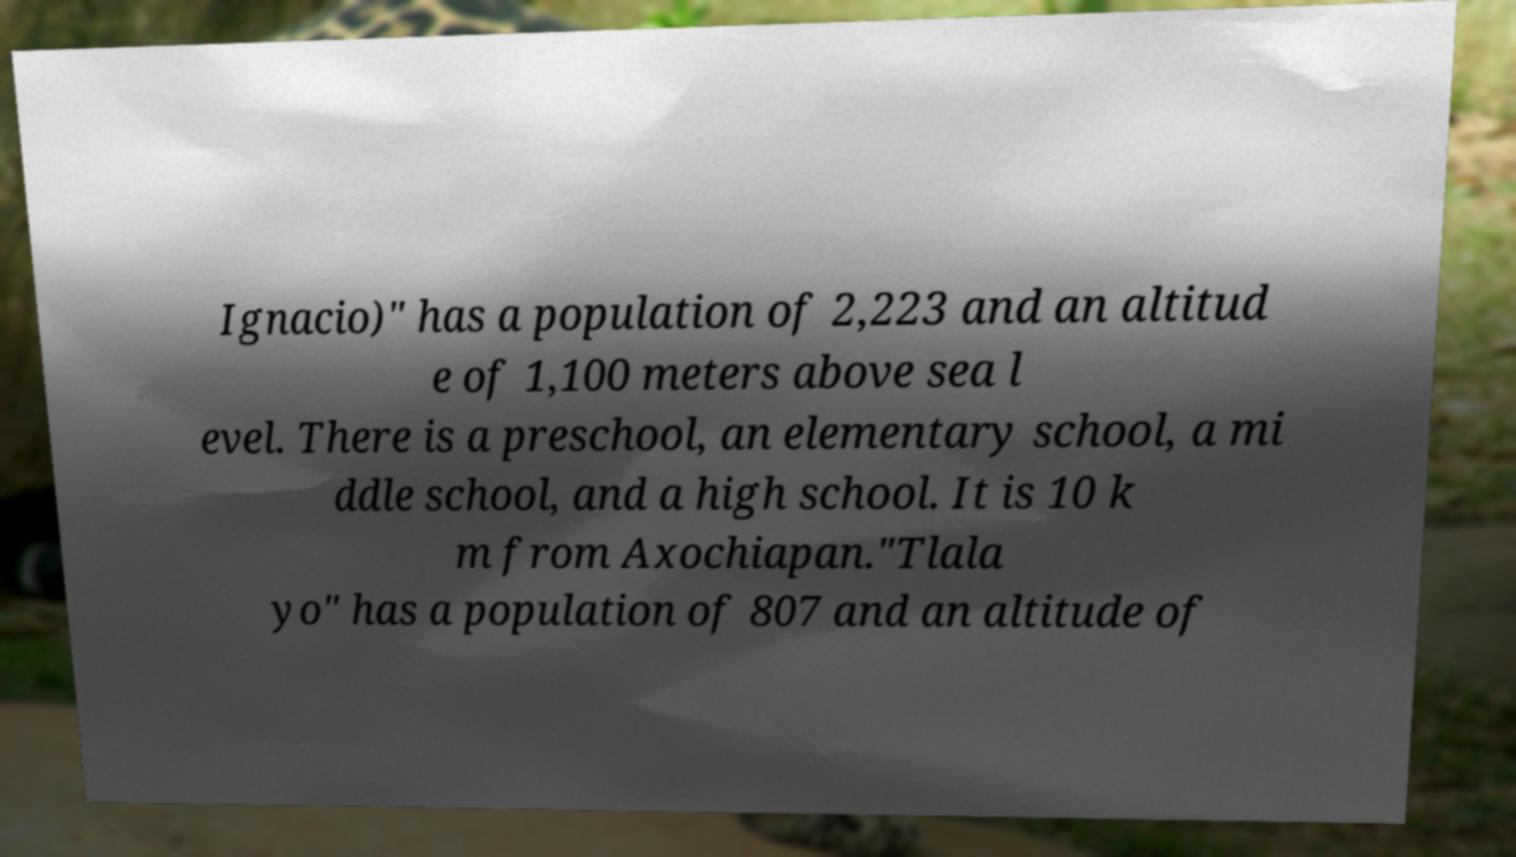For documentation purposes, I need the text within this image transcribed. Could you provide that? Ignacio)" has a population of 2,223 and an altitud e of 1,100 meters above sea l evel. There is a preschool, an elementary school, a mi ddle school, and a high school. It is 10 k m from Axochiapan."Tlala yo" has a population of 807 and an altitude of 